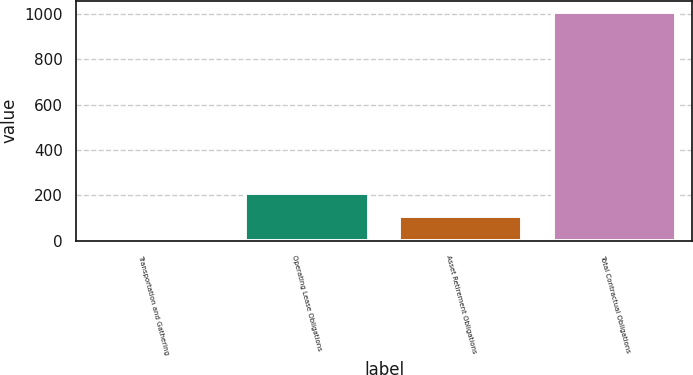Convert chart to OTSL. <chart><loc_0><loc_0><loc_500><loc_500><bar_chart><fcel>Transportation and Gathering<fcel>Operating Lease Obligations<fcel>Asset Retirement Obligations<fcel>Total Contractual Obligations<nl><fcel>9<fcel>209<fcel>109<fcel>1009<nl></chart> 